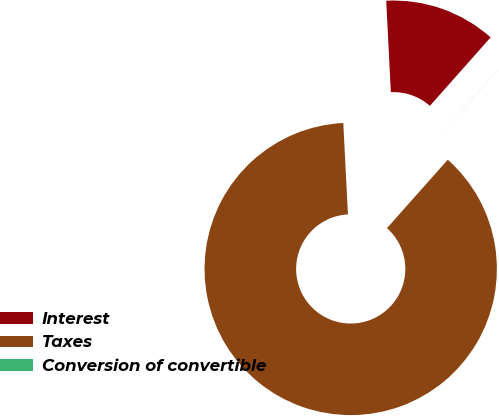<chart> <loc_0><loc_0><loc_500><loc_500><pie_chart><fcel>Interest<fcel>Taxes<fcel>Conversion of convertible<nl><fcel>12.36%<fcel>87.64%<fcel>0.01%<nl></chart> 